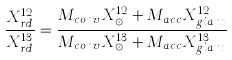<formula> <loc_0><loc_0><loc_500><loc_500>\frac { X ^ { 1 2 } _ { r d } } { X ^ { 1 3 } _ { r d } } = \frac { M _ { c o n v } X _ { \odot } ^ { 1 2 } + M _ { a c c } X _ { g i a n t } ^ { 1 2 } } { M _ { c o n v } X _ { \odot } ^ { 1 3 } + M _ { a c c } X _ { g i a n t } ^ { 1 3 } }</formula> 